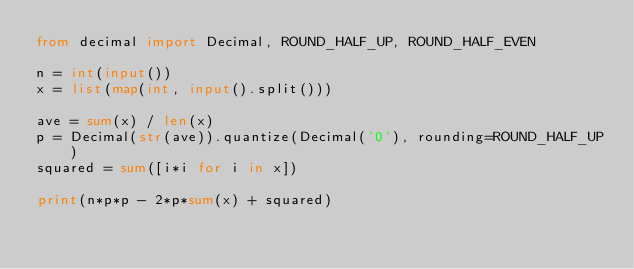<code> <loc_0><loc_0><loc_500><loc_500><_Python_>from decimal import Decimal, ROUND_HALF_UP, ROUND_HALF_EVEN

n = int(input())
x = list(map(int, input().split()))

ave = sum(x) / len(x)
p = Decimal(str(ave)).quantize(Decimal('0'), rounding=ROUND_HALF_UP)
squared = sum([i*i for i in x])

print(n*p*p - 2*p*sum(x) + squared)</code> 